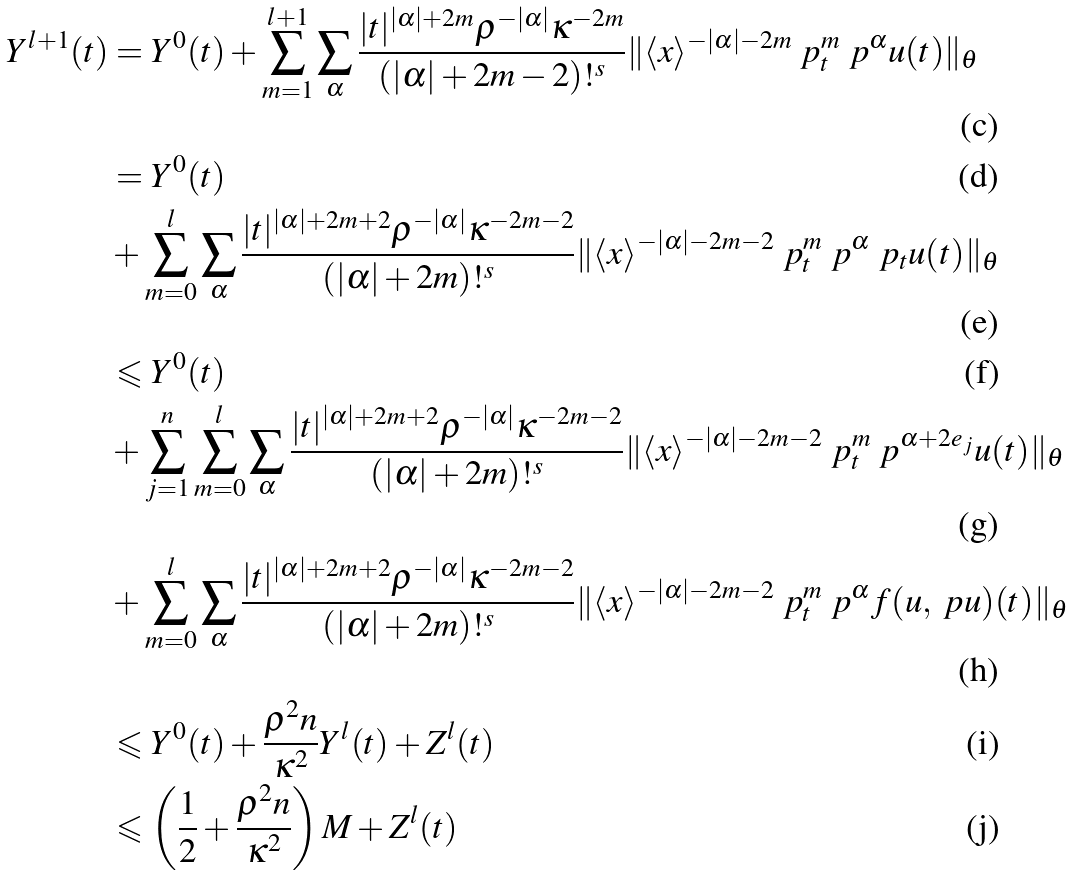Convert formula to latex. <formula><loc_0><loc_0><loc_500><loc_500>Y ^ { l + 1 } ( t ) & = Y ^ { 0 } ( t ) + \sum _ { m = 1 } ^ { l + 1 } \sum _ { \alpha } \frac { | { t } | ^ { | \alpha | + 2 m } \rho ^ { - | \alpha | } \kappa ^ { - 2 m } } { ( | \alpha | + 2 m - 2 ) ! ^ { s } } \| \langle { x } \rangle ^ { - | \alpha | - 2 m } \ p _ { t } ^ { m } \ p ^ { \alpha } { u ( t ) } \| _ { \theta } \\ & = Y ^ { 0 } ( t ) \\ & + \sum _ { m = 0 } ^ { l } \sum _ { \alpha } \frac { | { t } | ^ { | \alpha | + 2 m + 2 } \rho ^ { - | \alpha | } \kappa ^ { - 2 m - 2 } } { ( | \alpha | + 2 m ) ! ^ { s } } \| \langle { x } \rangle ^ { - | \alpha | - 2 m - 2 } \ p _ { t } ^ { m } \ p ^ { \alpha } \ p _ { t } u ( t ) \| _ { \theta } \\ & \leqslant Y ^ { 0 } ( t ) \\ & + \sum _ { j = 1 } ^ { n } \sum _ { m = 0 } ^ { l } \sum _ { \alpha } \frac { | { t } | ^ { | \alpha | + 2 m + 2 } \rho ^ { - | \alpha | } \kappa ^ { - 2 m - 2 } } { ( | \alpha | + 2 m ) ! ^ { s } } \| \langle { x } \rangle ^ { - | \alpha | - 2 m - 2 } \ p _ { t } ^ { m } \ p ^ { \alpha + 2 e _ { j } } u ( t ) \| _ { \theta } \\ & + \sum _ { m = 0 } ^ { l } \sum _ { \alpha } \frac { | { t } | ^ { | \alpha | + 2 m + 2 } \rho ^ { - | \alpha | } \kappa ^ { - 2 m - 2 } } { ( | \alpha | + 2 m ) ! ^ { s } } \| \langle { x } \rangle ^ { - | \alpha | - 2 m - 2 } \ p _ { t } ^ { m } \ p ^ { \alpha } f ( u , \ p { u } ) ( t ) \| _ { \theta } \\ & \leqslant Y ^ { 0 } ( t ) + \frac { \rho ^ { 2 } n } { \kappa ^ { 2 } } Y ^ { l } ( t ) + Z ^ { l } ( t ) \\ & \leqslant \left ( \frac { 1 } { 2 } + \frac { \rho ^ { 2 } n } { \kappa ^ { 2 } } \right ) M + Z ^ { l } ( t )</formula> 